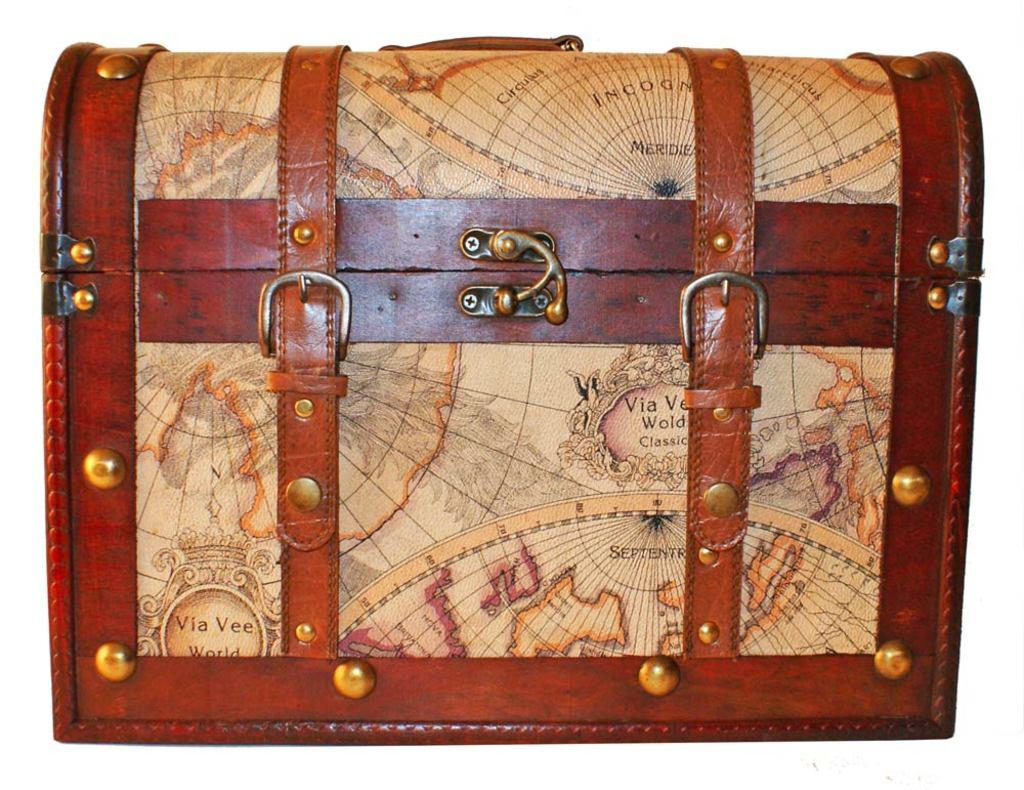What object can be seen in the image? There is a box in the image. How many pies are being served on the statement in the image? There are no pies or statements present in the image; it only features a box. 